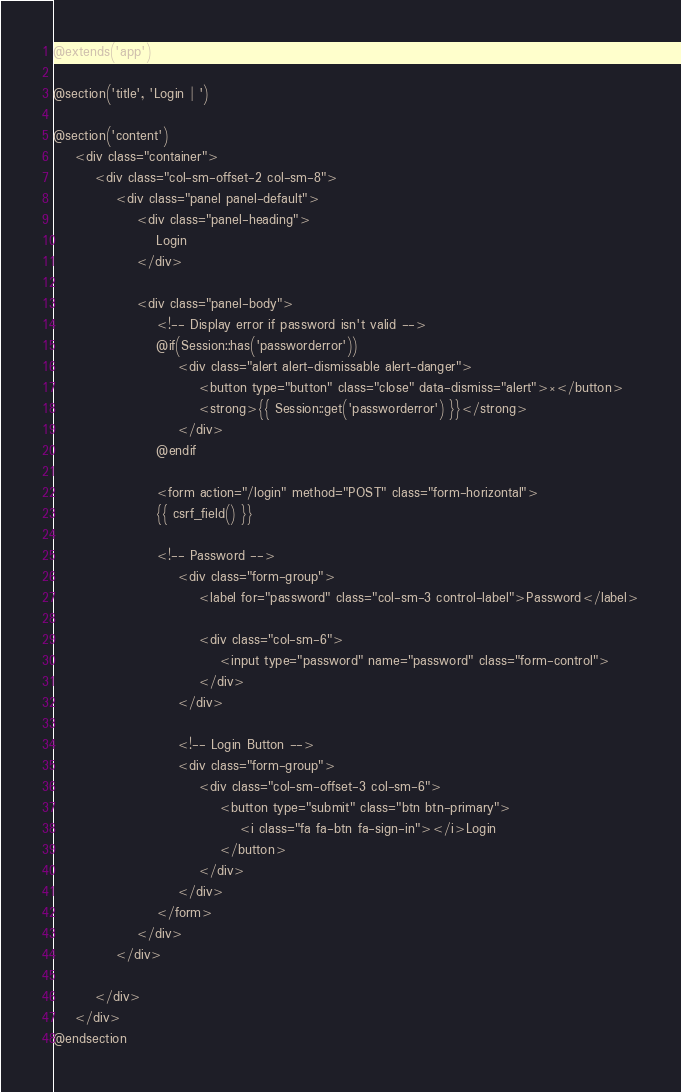<code> <loc_0><loc_0><loc_500><loc_500><_PHP_>@extends('app')

@section('title', 'Login | ')

@section('content')
    <div class="container">
        <div class="col-sm-offset-2 col-sm-8">
            <div class="panel panel-default">
                <div class="panel-heading">
                    Login
                </div>

                <div class="panel-body">
                    <!-- Display error if password isn't valid -->
                    @if(Session::has('passworderror'))
                        <div class="alert alert-dismissable alert-danger">
                            <button type="button" class="close" data-dismiss="alert">×</button>
                            <strong>{{ Session::get('passworderror') }}</strong>
                        </div>
                    @endif

                    <form action="/login" method="POST" class="form-horizontal">
                    {{ csrf_field() }}

                    <!-- Password -->
                        <div class="form-group">
                            <label for="password" class="col-sm-3 control-label">Password</label>

                            <div class="col-sm-6">
                                <input type="password" name="password" class="form-control">
                            </div>
                        </div>

                        <!-- Login Button -->
                        <div class="form-group">
                            <div class="col-sm-offset-3 col-sm-6">
                                <button type="submit" class="btn btn-primary">
                                    <i class="fa fa-btn fa-sign-in"></i>Login
                                </button>
                            </div>
                        </div>
                    </form>
                </div>
            </div>

        </div>
    </div>
@endsection</code> 